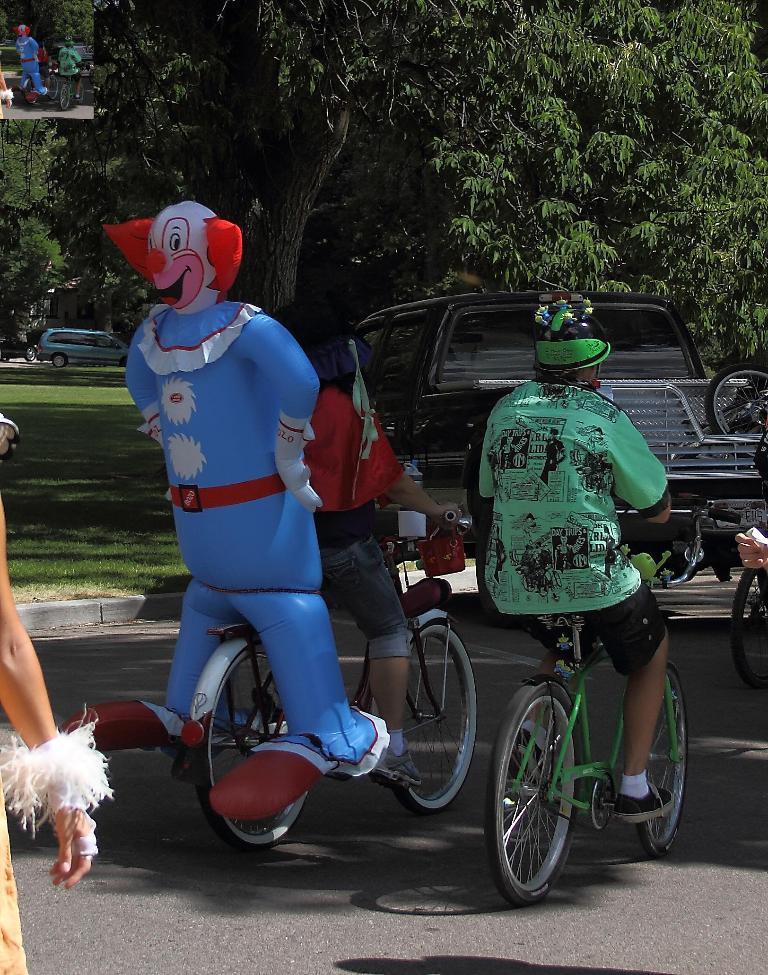Could you give a brief overview of what you see in this image? There are two persons riding a bicycle. Behind them there is a toy. And we can see a car. In the background there is a tree. In the bottom there is a car and a grass. In to the left side corner we can see a person. 